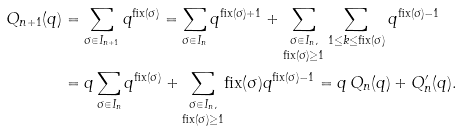Convert formula to latex. <formula><loc_0><loc_0><loc_500><loc_500>Q _ { n + 1 } ( q ) & = \sum _ { \sigma \in I _ { n + 1 } } q ^ { \text {fix} ( \sigma ) } = \sum _ { \sigma \in I _ { n } } q ^ { \text {fix} ( \sigma ) + 1 } + \underset { \text {fix} ( \sigma ) \geq 1 } { \sum _ { \sigma \in I _ { n } , } } \sum _ { 1 \leq k \leq \text {fix} ( \sigma ) } q ^ { \text {fix} ( \sigma ) - 1 } \\ & = q \sum _ { \sigma \in I _ { n } } q ^ { \text {fix} ( \sigma ) } + \underset { \text {fix} ( \sigma ) \geq 1 } { \sum _ { \sigma \in I _ { n } , } } \text {fix} ( \sigma ) q ^ { \text {fix} ( \sigma ) - 1 } = q \, Q _ { n } ( q ) + Q _ { n } ^ { \prime } ( q ) .</formula> 